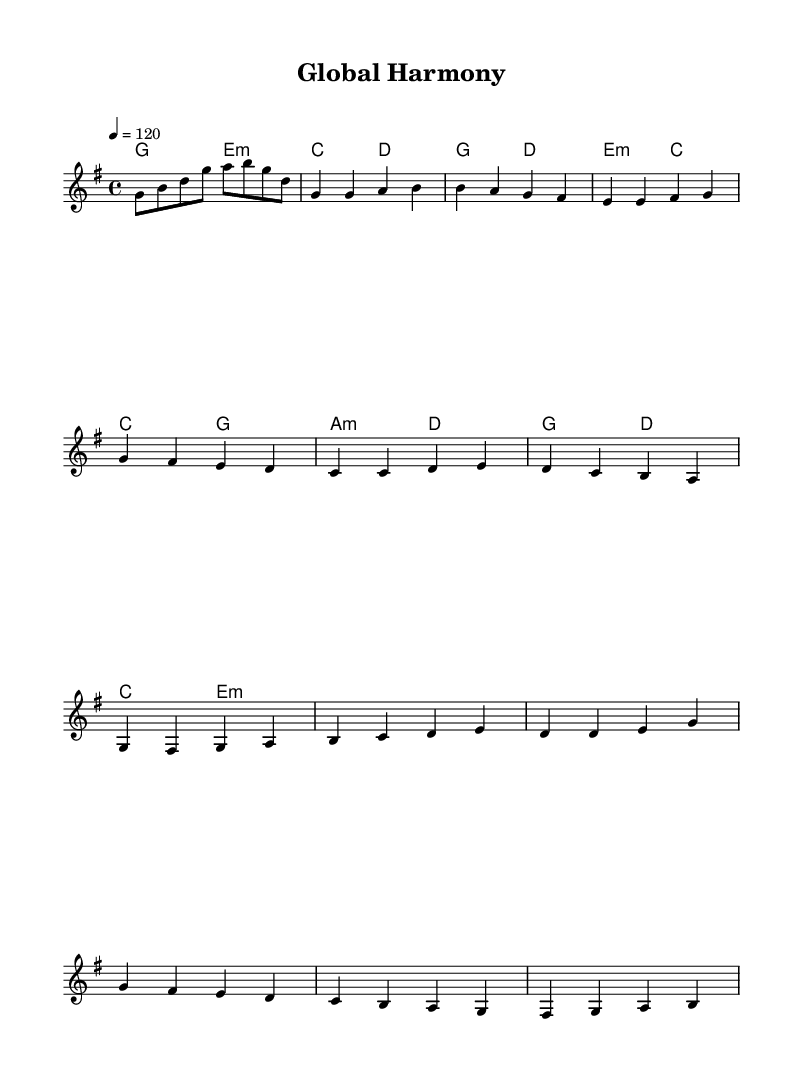What is the key signature of this music? The key signature is indicated at the beginning of the staff, showing one sharp, which represents the G major scale.
Answer: G major What is the time signature of this piece? The time signature appears prominently at the beginning, indicating that there are four beats in each measure, which is specified as 4/4.
Answer: 4/4 What is the tempo marking of the music? The tempo marking is located above the staff, showing that the piece should be played at a speed of 120 beats per minute.
Answer: 120 How many measures are in the chorus? By counting the measures in the section labeled "Chorus" within the score, there are a total of 4 measures indicated.
Answer: 4 What is the first chord in the piece? The first chord is depicted at the start of the score under the chord names and is identified as G major, based on the musical notation.
Answer: G In which section does the melody primarily ascend? Analyzing the melody line throughout the score, it is noted that the first half of the "Pre-Chorus" shows a clear upward movement in pitch, especially in measures where notes go from lower to higher.
Answer: Pre-Chorus What type of harmonic progression is evident in the chorus? By examining the chords used in the chorus, it is clear that a common pop harmonic progression is utilized, particularly using the G major and D major chords prominently.
Answer: Common pop progression 